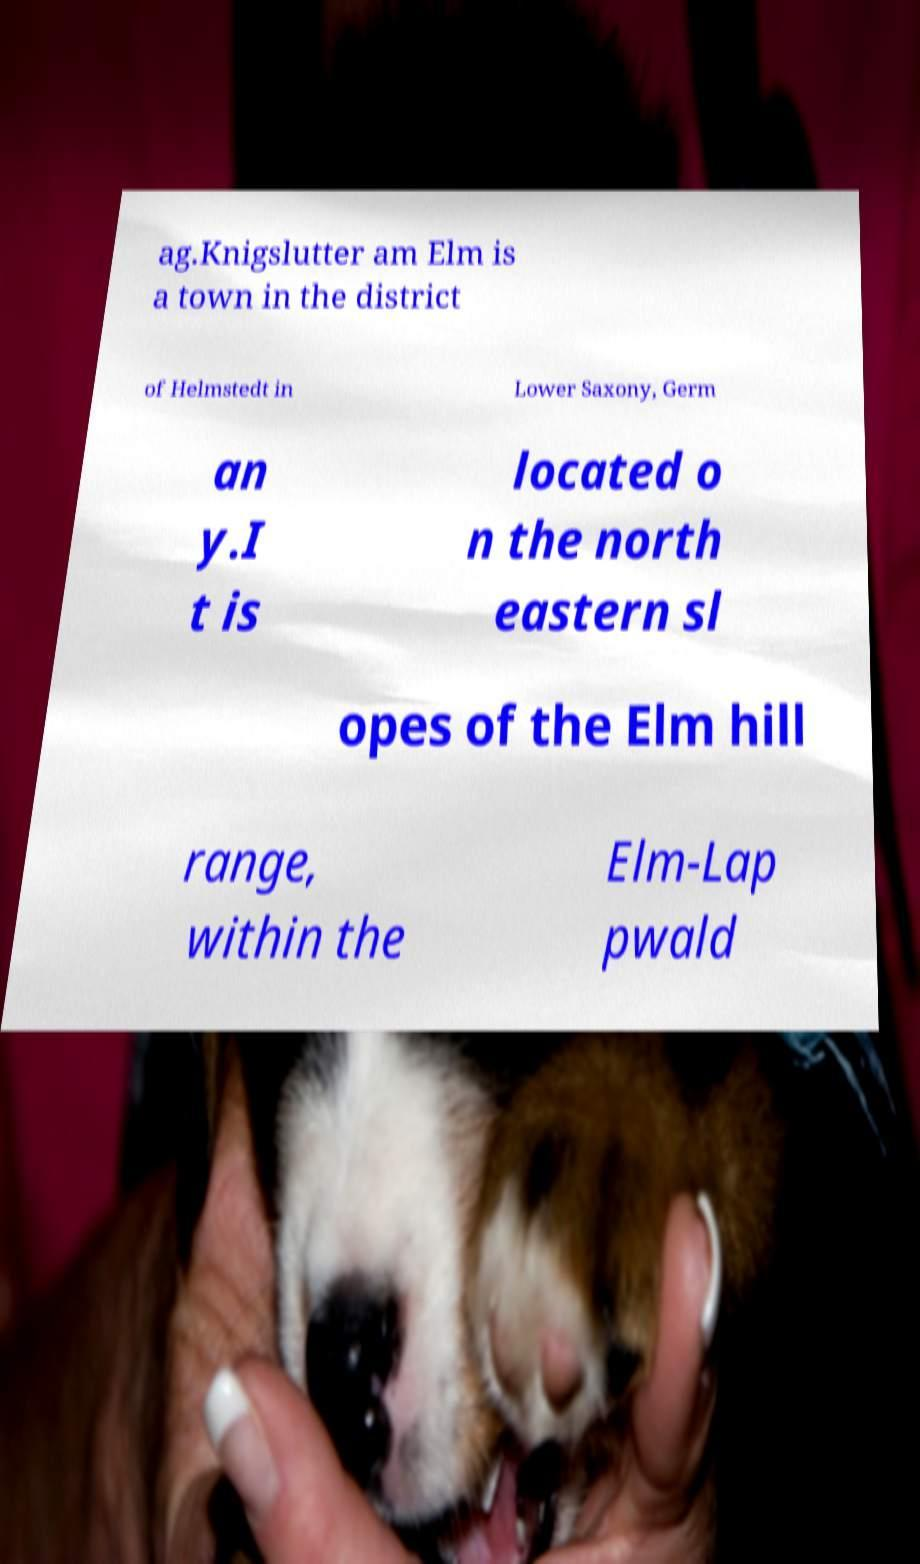Please read and relay the text visible in this image. What does it say? ag.Knigslutter am Elm is a town in the district of Helmstedt in Lower Saxony, Germ an y.I t is located o n the north eastern sl opes of the Elm hill range, within the Elm-Lap pwald 